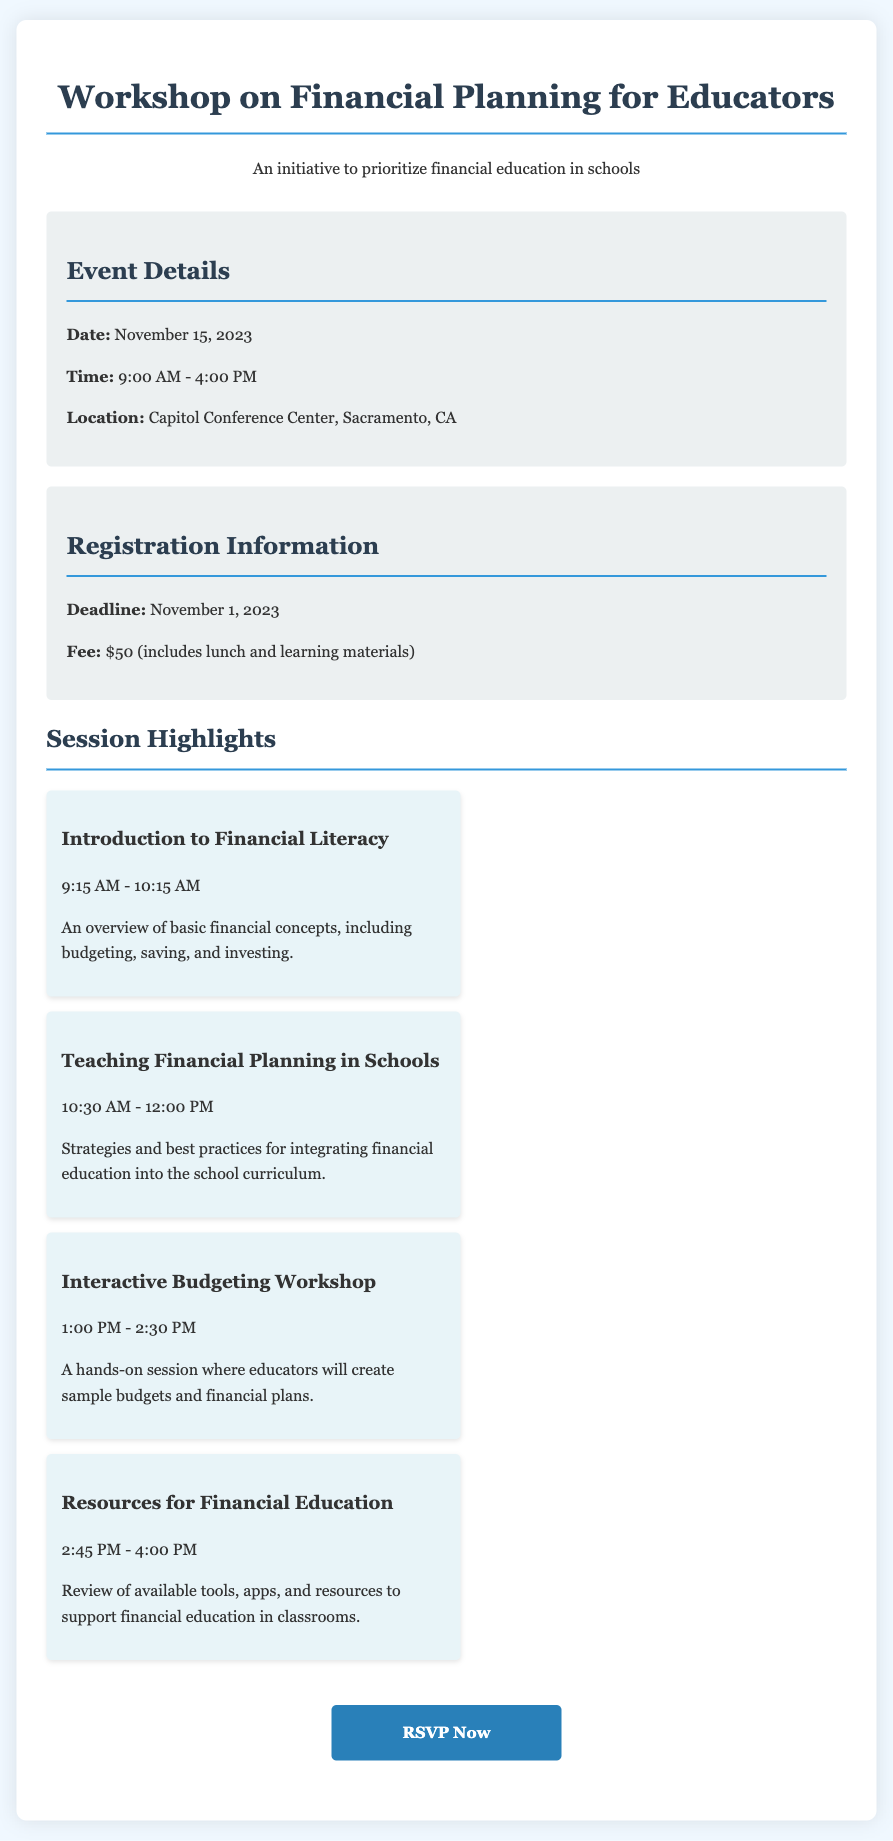What is the date of the workshop? The date of the workshop is stated in the document as November 15, 2023.
Answer: November 15, 2023 What time does the workshop start? The starting time of the workshop is mentioned as 9:00 AM.
Answer: 9:00 AM Where is the workshop being held? The location given in the document for the workshop is the Capitol Conference Center, Sacramento, CA.
Answer: Capitol Conference Center, Sacramento, CA What is the registration deadline? The document specifies that the registration deadline is November 1, 2023.
Answer: November 1, 2023 How much is the registration fee? The document mentions the registration fee as $50.
Answer: $50 What session discusses budgeting? The session on budgeting is titled "Interactive Budgeting Workshop," as stated in the document.
Answer: Interactive Budgeting Workshop How long is the session on "Teaching Financial Planning in Schools"? The duration of this session is from 10:30 AM to 12:00 PM, indicating it lasts 1.5 hours.
Answer: 1.5 hours Which session occurs last during the day? The final session listed in the document is "Resources for Financial Education."
Answer: Resources for Financial Education What does the registration fee include? The document states that the fee includes lunch and learning materials.
Answer: Lunch and learning materials What type of document is this? This document serves as an RSVP card for a workshop.
Answer: RSVP card 